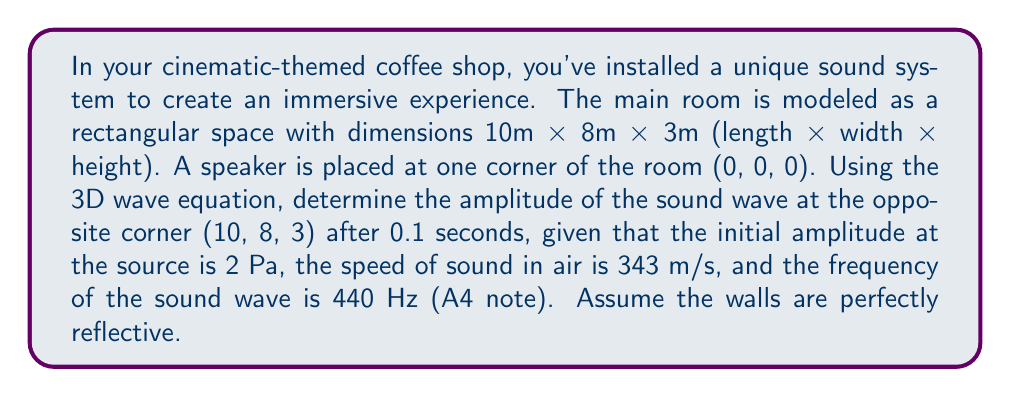Help me with this question. To solve this problem, we'll use the 3D wave equation and apply the given boundary conditions:

1) The 3D wave equation is:

   $$\frac{\partial^2 u}{\partial t^2} = c^2 \left(\frac{\partial^2 u}{\partial x^2} + \frac{\partial^2 u}{\partial y^2} + \frac{\partial^2 u}{\partial z^2}\right)$$

   where $u$ is the amplitude, $t$ is time, $c$ is the speed of sound, and $x$, $y$, $z$ are spatial coordinates.

2) For a point source in a rectangular room with perfectly reflective walls, the solution can be expressed as:

   $$u(x,y,z,t) = \frac{A}{r} \sin(2\pi ft - kr)$$

   where $A$ is the initial amplitude, $r$ is the distance from the source, $f$ is the frequency, $k$ is the wave number $(k = 2\pi f/c)$, and $t$ is time.

3) Calculate the distance $r$ from the source (0, 0, 0) to the point (10, 8, 3):

   $$r = \sqrt{10^2 + 8^2 + 3^2} = \sqrt{173} \approx 13.15 \text{ m}$$

4) Calculate the wave number $k$:

   $$k = \frac{2\pi f}{c} = \frac{2\pi \cdot 440}{343} \approx 8.05 \text{ m}^{-1}$$

5) Now, we can substitute these values into our solution:

   $$u(10,8,3,0.1) = \frac{2}{\sqrt{173}} \sin(2\pi \cdot 440 \cdot 0.1 - 8.05 \cdot \sqrt{173})$$

6) Simplify:

   $$u(10,8,3,0.1) \approx 0.152 \sin(276.46 - 105.86) \approx 0.152 \sin(170.60) \approx 0.150 \text{ Pa}$$

Therefore, the amplitude of the sound wave at the opposite corner after 0.1 seconds is approximately 0.150 Pa.
Answer: 0.150 Pa 